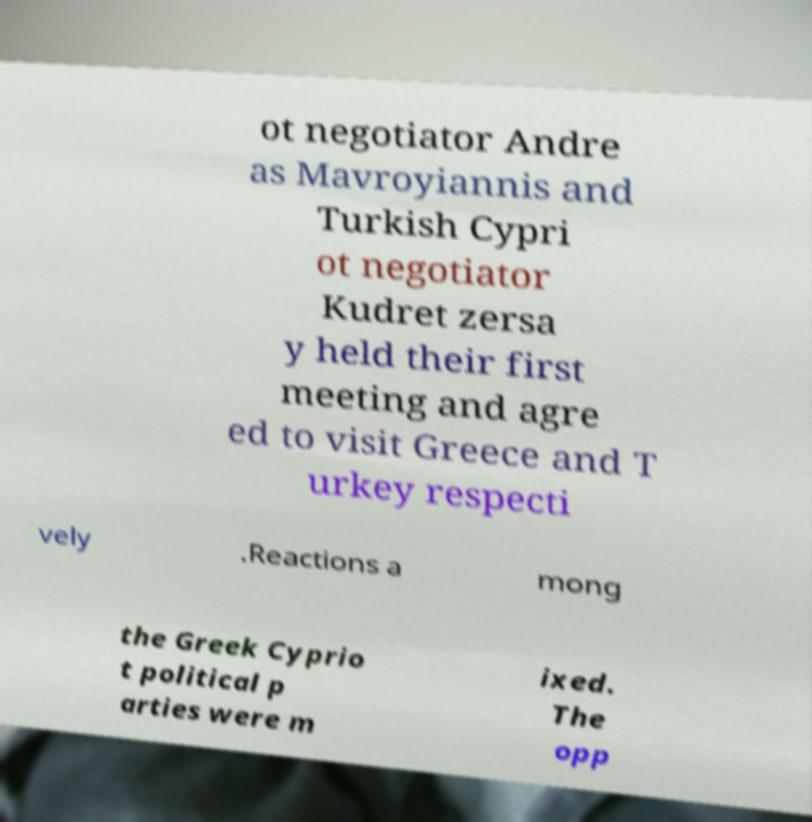For documentation purposes, I need the text within this image transcribed. Could you provide that? ot negotiator Andre as Mavroyiannis and Turkish Cypri ot negotiator Kudret zersa y held their first meeting and agre ed to visit Greece and T urkey respecti vely .Reactions a mong the Greek Cyprio t political p arties were m ixed. The opp 